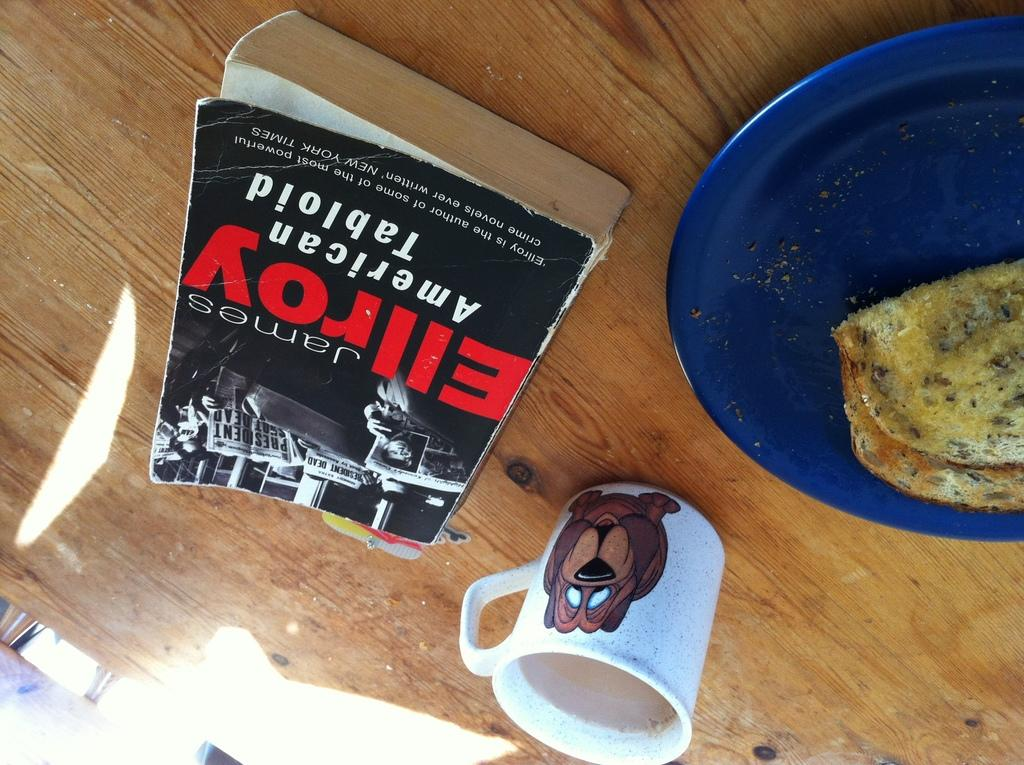<image>
Write a terse but informative summary of the picture. American Tabloid sits on a wooden table next to a coffee cup and some eggs. 